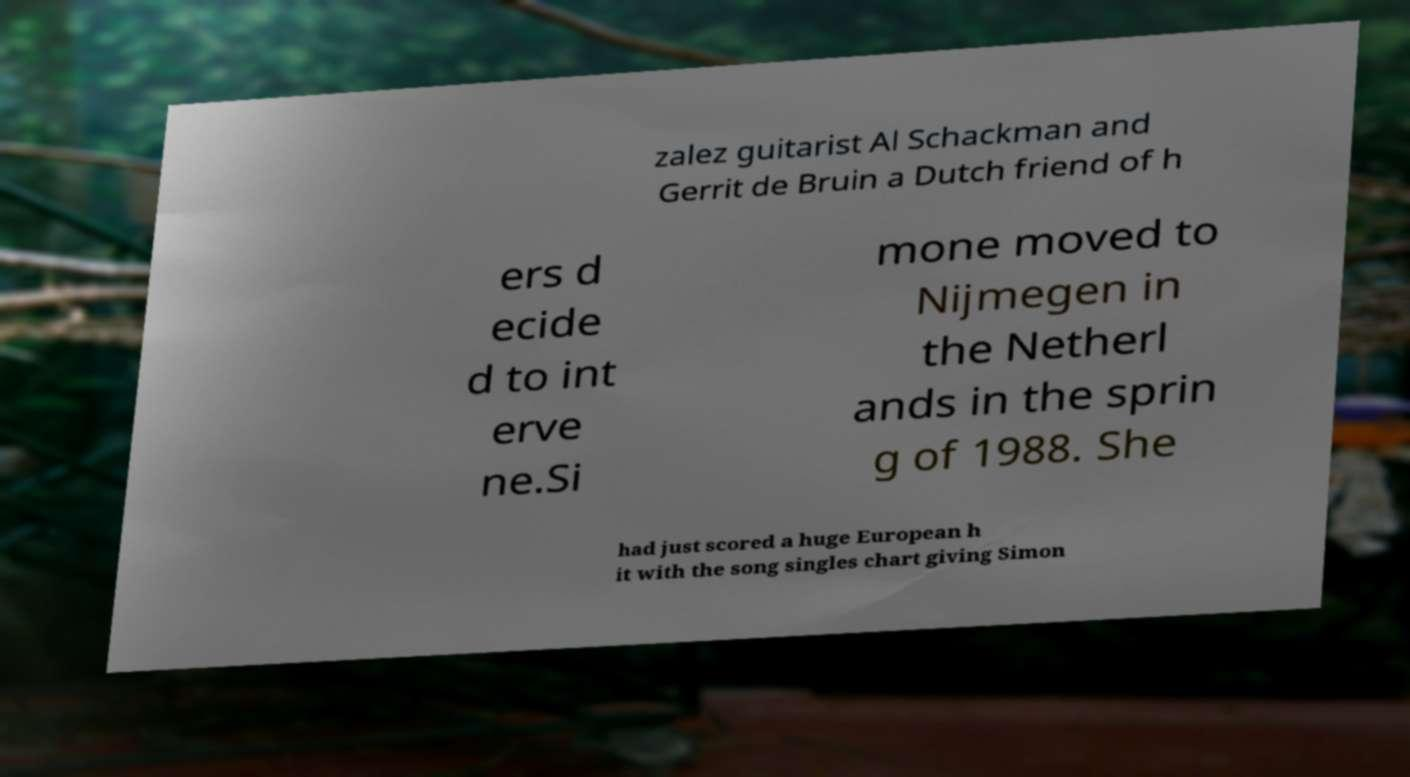Could you assist in decoding the text presented in this image and type it out clearly? zalez guitarist Al Schackman and Gerrit de Bruin a Dutch friend of h ers d ecide d to int erve ne.Si mone moved to Nijmegen in the Netherl ands in the sprin g of 1988. She had just scored a huge European h it with the song singles chart giving Simon 